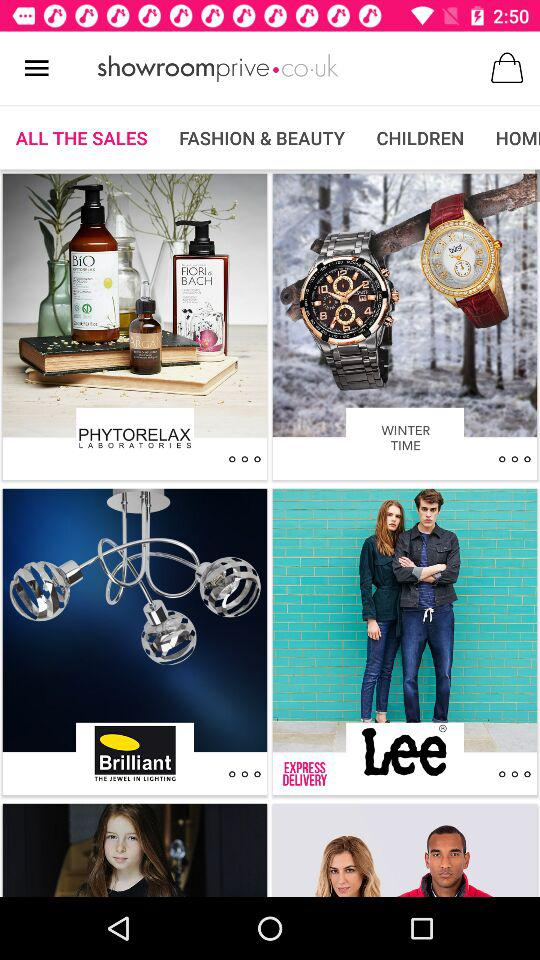What is the application name? The application name is "showroomprive.co.uk". 